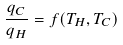Convert formula to latex. <formula><loc_0><loc_0><loc_500><loc_500>\frac { q _ { C } } { q _ { H } } = f ( T _ { H } , T _ { C } )</formula> 